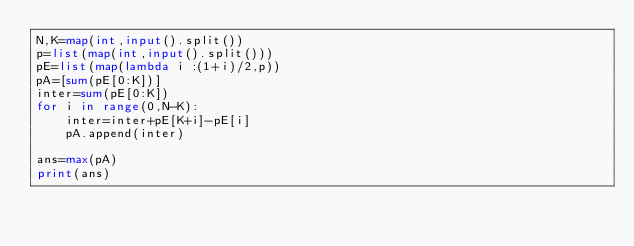Convert code to text. <code><loc_0><loc_0><loc_500><loc_500><_Python_>N,K=map(int,input().split())
p=list(map(int,input().split()))
pE=list(map(lambda i :(1+i)/2,p))
pA=[sum(pE[0:K])]
inter=sum(pE[0:K])
for i in range(0,N-K):
    inter=inter+pE[K+i]-pE[i]
    pA.append(inter)

ans=max(pA)
print(ans)

</code> 